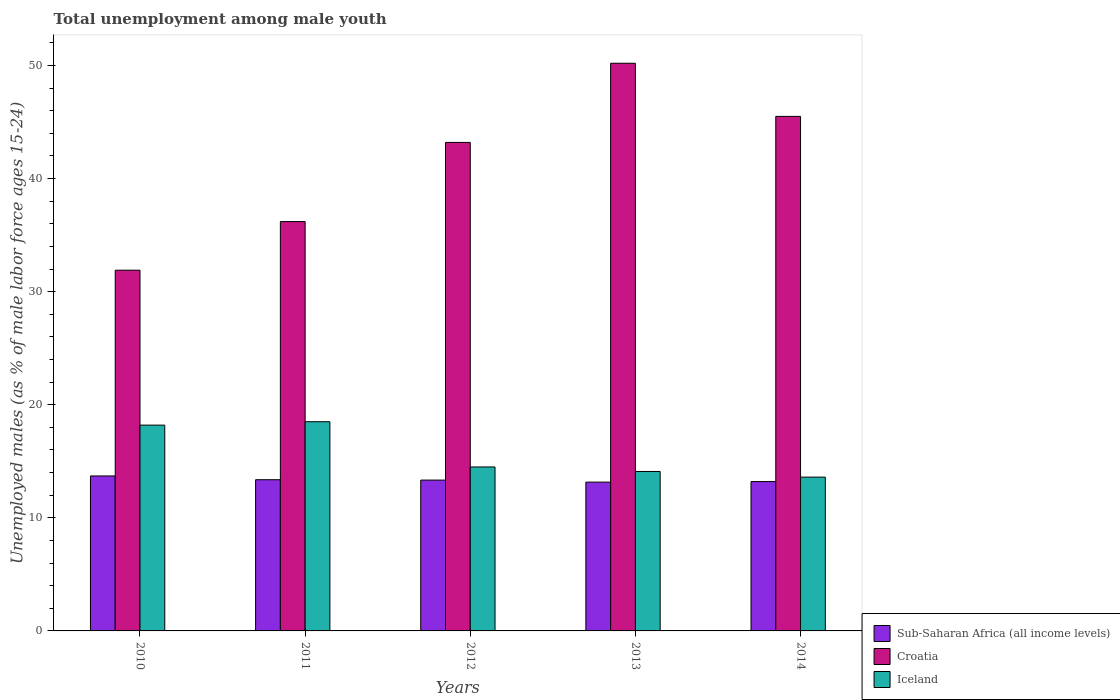How many different coloured bars are there?
Provide a succinct answer. 3. How many groups of bars are there?
Give a very brief answer. 5. How many bars are there on the 1st tick from the left?
Keep it short and to the point. 3. What is the percentage of unemployed males in in Sub-Saharan Africa (all income levels) in 2012?
Your answer should be compact. 13.34. Across all years, what is the maximum percentage of unemployed males in in Iceland?
Your answer should be very brief. 18.5. Across all years, what is the minimum percentage of unemployed males in in Sub-Saharan Africa (all income levels)?
Your answer should be compact. 13.16. In which year was the percentage of unemployed males in in Sub-Saharan Africa (all income levels) minimum?
Your response must be concise. 2013. What is the total percentage of unemployed males in in Sub-Saharan Africa (all income levels) in the graph?
Keep it short and to the point. 66.78. What is the difference between the percentage of unemployed males in in Croatia in 2012 and that in 2014?
Your response must be concise. -2.3. What is the difference between the percentage of unemployed males in in Iceland in 2014 and the percentage of unemployed males in in Sub-Saharan Africa (all income levels) in 2013?
Provide a short and direct response. 0.44. What is the average percentage of unemployed males in in Croatia per year?
Your answer should be very brief. 41.4. In the year 2014, what is the difference between the percentage of unemployed males in in Croatia and percentage of unemployed males in in Sub-Saharan Africa (all income levels)?
Your answer should be compact. 32.29. In how many years, is the percentage of unemployed males in in Sub-Saharan Africa (all income levels) greater than 26 %?
Offer a very short reply. 0. What is the ratio of the percentage of unemployed males in in Croatia in 2010 to that in 2011?
Your answer should be very brief. 0.88. Is the percentage of unemployed males in in Iceland in 2011 less than that in 2013?
Your answer should be very brief. No. Is the difference between the percentage of unemployed males in in Croatia in 2011 and 2013 greater than the difference between the percentage of unemployed males in in Sub-Saharan Africa (all income levels) in 2011 and 2013?
Ensure brevity in your answer.  No. What is the difference between the highest and the second highest percentage of unemployed males in in Iceland?
Give a very brief answer. 0.3. What is the difference between the highest and the lowest percentage of unemployed males in in Sub-Saharan Africa (all income levels)?
Your answer should be compact. 0.55. In how many years, is the percentage of unemployed males in in Sub-Saharan Africa (all income levels) greater than the average percentage of unemployed males in in Sub-Saharan Africa (all income levels) taken over all years?
Your answer should be compact. 2. Is the sum of the percentage of unemployed males in in Sub-Saharan Africa (all income levels) in 2013 and 2014 greater than the maximum percentage of unemployed males in in Croatia across all years?
Make the answer very short. No. What does the 1st bar from the left in 2011 represents?
Give a very brief answer. Sub-Saharan Africa (all income levels). What does the 2nd bar from the right in 2014 represents?
Keep it short and to the point. Croatia. How many bars are there?
Your answer should be very brief. 15. Are all the bars in the graph horizontal?
Your answer should be compact. No. Are the values on the major ticks of Y-axis written in scientific E-notation?
Your answer should be compact. No. Does the graph contain any zero values?
Offer a very short reply. No. Does the graph contain grids?
Offer a very short reply. No. Where does the legend appear in the graph?
Ensure brevity in your answer.  Bottom right. How many legend labels are there?
Your answer should be very brief. 3. What is the title of the graph?
Keep it short and to the point. Total unemployment among male youth. Does "Morocco" appear as one of the legend labels in the graph?
Your response must be concise. No. What is the label or title of the Y-axis?
Provide a short and direct response. Unemployed males (as % of male labor force ages 15-24). What is the Unemployed males (as % of male labor force ages 15-24) of Sub-Saharan Africa (all income levels) in 2010?
Your response must be concise. 13.7. What is the Unemployed males (as % of male labor force ages 15-24) in Croatia in 2010?
Provide a succinct answer. 31.9. What is the Unemployed males (as % of male labor force ages 15-24) in Iceland in 2010?
Keep it short and to the point. 18.2. What is the Unemployed males (as % of male labor force ages 15-24) of Sub-Saharan Africa (all income levels) in 2011?
Your response must be concise. 13.37. What is the Unemployed males (as % of male labor force ages 15-24) in Croatia in 2011?
Offer a very short reply. 36.2. What is the Unemployed males (as % of male labor force ages 15-24) of Iceland in 2011?
Offer a very short reply. 18.5. What is the Unemployed males (as % of male labor force ages 15-24) in Sub-Saharan Africa (all income levels) in 2012?
Give a very brief answer. 13.34. What is the Unemployed males (as % of male labor force ages 15-24) in Croatia in 2012?
Offer a terse response. 43.2. What is the Unemployed males (as % of male labor force ages 15-24) of Sub-Saharan Africa (all income levels) in 2013?
Ensure brevity in your answer.  13.16. What is the Unemployed males (as % of male labor force ages 15-24) in Croatia in 2013?
Offer a terse response. 50.2. What is the Unemployed males (as % of male labor force ages 15-24) in Iceland in 2013?
Provide a succinct answer. 14.1. What is the Unemployed males (as % of male labor force ages 15-24) of Sub-Saharan Africa (all income levels) in 2014?
Make the answer very short. 13.21. What is the Unemployed males (as % of male labor force ages 15-24) in Croatia in 2014?
Provide a short and direct response. 45.5. What is the Unemployed males (as % of male labor force ages 15-24) of Iceland in 2014?
Ensure brevity in your answer.  13.6. Across all years, what is the maximum Unemployed males (as % of male labor force ages 15-24) of Sub-Saharan Africa (all income levels)?
Your answer should be very brief. 13.7. Across all years, what is the maximum Unemployed males (as % of male labor force ages 15-24) of Croatia?
Offer a very short reply. 50.2. Across all years, what is the maximum Unemployed males (as % of male labor force ages 15-24) of Iceland?
Offer a very short reply. 18.5. Across all years, what is the minimum Unemployed males (as % of male labor force ages 15-24) in Sub-Saharan Africa (all income levels)?
Your answer should be very brief. 13.16. Across all years, what is the minimum Unemployed males (as % of male labor force ages 15-24) in Croatia?
Keep it short and to the point. 31.9. Across all years, what is the minimum Unemployed males (as % of male labor force ages 15-24) in Iceland?
Provide a succinct answer. 13.6. What is the total Unemployed males (as % of male labor force ages 15-24) in Sub-Saharan Africa (all income levels) in the graph?
Ensure brevity in your answer.  66.78. What is the total Unemployed males (as % of male labor force ages 15-24) in Croatia in the graph?
Provide a succinct answer. 207. What is the total Unemployed males (as % of male labor force ages 15-24) of Iceland in the graph?
Provide a short and direct response. 78.9. What is the difference between the Unemployed males (as % of male labor force ages 15-24) in Sub-Saharan Africa (all income levels) in 2010 and that in 2012?
Ensure brevity in your answer.  0.37. What is the difference between the Unemployed males (as % of male labor force ages 15-24) of Croatia in 2010 and that in 2012?
Make the answer very short. -11.3. What is the difference between the Unemployed males (as % of male labor force ages 15-24) of Iceland in 2010 and that in 2012?
Keep it short and to the point. 3.7. What is the difference between the Unemployed males (as % of male labor force ages 15-24) of Sub-Saharan Africa (all income levels) in 2010 and that in 2013?
Provide a succinct answer. 0.55. What is the difference between the Unemployed males (as % of male labor force ages 15-24) of Croatia in 2010 and that in 2013?
Offer a very short reply. -18.3. What is the difference between the Unemployed males (as % of male labor force ages 15-24) of Iceland in 2010 and that in 2013?
Offer a very short reply. 4.1. What is the difference between the Unemployed males (as % of male labor force ages 15-24) of Sub-Saharan Africa (all income levels) in 2010 and that in 2014?
Your answer should be very brief. 0.5. What is the difference between the Unemployed males (as % of male labor force ages 15-24) of Croatia in 2010 and that in 2014?
Your answer should be compact. -13.6. What is the difference between the Unemployed males (as % of male labor force ages 15-24) in Iceland in 2010 and that in 2014?
Provide a short and direct response. 4.6. What is the difference between the Unemployed males (as % of male labor force ages 15-24) of Sub-Saharan Africa (all income levels) in 2011 and that in 2012?
Offer a terse response. 0.03. What is the difference between the Unemployed males (as % of male labor force ages 15-24) of Iceland in 2011 and that in 2012?
Your response must be concise. 4. What is the difference between the Unemployed males (as % of male labor force ages 15-24) in Sub-Saharan Africa (all income levels) in 2011 and that in 2013?
Ensure brevity in your answer.  0.21. What is the difference between the Unemployed males (as % of male labor force ages 15-24) in Croatia in 2011 and that in 2013?
Your answer should be compact. -14. What is the difference between the Unemployed males (as % of male labor force ages 15-24) in Sub-Saharan Africa (all income levels) in 2011 and that in 2014?
Ensure brevity in your answer.  0.16. What is the difference between the Unemployed males (as % of male labor force ages 15-24) of Croatia in 2011 and that in 2014?
Ensure brevity in your answer.  -9.3. What is the difference between the Unemployed males (as % of male labor force ages 15-24) of Sub-Saharan Africa (all income levels) in 2012 and that in 2013?
Offer a very short reply. 0.18. What is the difference between the Unemployed males (as % of male labor force ages 15-24) in Iceland in 2012 and that in 2013?
Give a very brief answer. 0.4. What is the difference between the Unemployed males (as % of male labor force ages 15-24) in Sub-Saharan Africa (all income levels) in 2012 and that in 2014?
Offer a terse response. 0.13. What is the difference between the Unemployed males (as % of male labor force ages 15-24) in Croatia in 2012 and that in 2014?
Make the answer very short. -2.3. What is the difference between the Unemployed males (as % of male labor force ages 15-24) of Iceland in 2012 and that in 2014?
Give a very brief answer. 0.9. What is the difference between the Unemployed males (as % of male labor force ages 15-24) of Sub-Saharan Africa (all income levels) in 2013 and that in 2014?
Offer a very short reply. -0.05. What is the difference between the Unemployed males (as % of male labor force ages 15-24) of Sub-Saharan Africa (all income levels) in 2010 and the Unemployed males (as % of male labor force ages 15-24) of Croatia in 2011?
Offer a terse response. -22.5. What is the difference between the Unemployed males (as % of male labor force ages 15-24) of Sub-Saharan Africa (all income levels) in 2010 and the Unemployed males (as % of male labor force ages 15-24) of Iceland in 2011?
Offer a terse response. -4.8. What is the difference between the Unemployed males (as % of male labor force ages 15-24) in Sub-Saharan Africa (all income levels) in 2010 and the Unemployed males (as % of male labor force ages 15-24) in Croatia in 2012?
Provide a succinct answer. -29.5. What is the difference between the Unemployed males (as % of male labor force ages 15-24) of Sub-Saharan Africa (all income levels) in 2010 and the Unemployed males (as % of male labor force ages 15-24) of Iceland in 2012?
Offer a terse response. -0.8. What is the difference between the Unemployed males (as % of male labor force ages 15-24) in Croatia in 2010 and the Unemployed males (as % of male labor force ages 15-24) in Iceland in 2012?
Ensure brevity in your answer.  17.4. What is the difference between the Unemployed males (as % of male labor force ages 15-24) of Sub-Saharan Africa (all income levels) in 2010 and the Unemployed males (as % of male labor force ages 15-24) of Croatia in 2013?
Your answer should be very brief. -36.5. What is the difference between the Unemployed males (as % of male labor force ages 15-24) in Sub-Saharan Africa (all income levels) in 2010 and the Unemployed males (as % of male labor force ages 15-24) in Iceland in 2013?
Give a very brief answer. -0.4. What is the difference between the Unemployed males (as % of male labor force ages 15-24) in Croatia in 2010 and the Unemployed males (as % of male labor force ages 15-24) in Iceland in 2013?
Offer a very short reply. 17.8. What is the difference between the Unemployed males (as % of male labor force ages 15-24) of Sub-Saharan Africa (all income levels) in 2010 and the Unemployed males (as % of male labor force ages 15-24) of Croatia in 2014?
Provide a short and direct response. -31.8. What is the difference between the Unemployed males (as % of male labor force ages 15-24) in Sub-Saharan Africa (all income levels) in 2010 and the Unemployed males (as % of male labor force ages 15-24) in Iceland in 2014?
Keep it short and to the point. 0.1. What is the difference between the Unemployed males (as % of male labor force ages 15-24) in Croatia in 2010 and the Unemployed males (as % of male labor force ages 15-24) in Iceland in 2014?
Your response must be concise. 18.3. What is the difference between the Unemployed males (as % of male labor force ages 15-24) in Sub-Saharan Africa (all income levels) in 2011 and the Unemployed males (as % of male labor force ages 15-24) in Croatia in 2012?
Your response must be concise. -29.83. What is the difference between the Unemployed males (as % of male labor force ages 15-24) in Sub-Saharan Africa (all income levels) in 2011 and the Unemployed males (as % of male labor force ages 15-24) in Iceland in 2012?
Ensure brevity in your answer.  -1.13. What is the difference between the Unemployed males (as % of male labor force ages 15-24) in Croatia in 2011 and the Unemployed males (as % of male labor force ages 15-24) in Iceland in 2012?
Offer a terse response. 21.7. What is the difference between the Unemployed males (as % of male labor force ages 15-24) of Sub-Saharan Africa (all income levels) in 2011 and the Unemployed males (as % of male labor force ages 15-24) of Croatia in 2013?
Keep it short and to the point. -36.83. What is the difference between the Unemployed males (as % of male labor force ages 15-24) in Sub-Saharan Africa (all income levels) in 2011 and the Unemployed males (as % of male labor force ages 15-24) in Iceland in 2013?
Offer a terse response. -0.73. What is the difference between the Unemployed males (as % of male labor force ages 15-24) in Croatia in 2011 and the Unemployed males (as % of male labor force ages 15-24) in Iceland in 2013?
Provide a short and direct response. 22.1. What is the difference between the Unemployed males (as % of male labor force ages 15-24) of Sub-Saharan Africa (all income levels) in 2011 and the Unemployed males (as % of male labor force ages 15-24) of Croatia in 2014?
Give a very brief answer. -32.13. What is the difference between the Unemployed males (as % of male labor force ages 15-24) of Sub-Saharan Africa (all income levels) in 2011 and the Unemployed males (as % of male labor force ages 15-24) of Iceland in 2014?
Keep it short and to the point. -0.23. What is the difference between the Unemployed males (as % of male labor force ages 15-24) of Croatia in 2011 and the Unemployed males (as % of male labor force ages 15-24) of Iceland in 2014?
Provide a short and direct response. 22.6. What is the difference between the Unemployed males (as % of male labor force ages 15-24) in Sub-Saharan Africa (all income levels) in 2012 and the Unemployed males (as % of male labor force ages 15-24) in Croatia in 2013?
Your response must be concise. -36.86. What is the difference between the Unemployed males (as % of male labor force ages 15-24) in Sub-Saharan Africa (all income levels) in 2012 and the Unemployed males (as % of male labor force ages 15-24) in Iceland in 2013?
Ensure brevity in your answer.  -0.76. What is the difference between the Unemployed males (as % of male labor force ages 15-24) in Croatia in 2012 and the Unemployed males (as % of male labor force ages 15-24) in Iceland in 2013?
Provide a succinct answer. 29.1. What is the difference between the Unemployed males (as % of male labor force ages 15-24) in Sub-Saharan Africa (all income levels) in 2012 and the Unemployed males (as % of male labor force ages 15-24) in Croatia in 2014?
Offer a very short reply. -32.16. What is the difference between the Unemployed males (as % of male labor force ages 15-24) in Sub-Saharan Africa (all income levels) in 2012 and the Unemployed males (as % of male labor force ages 15-24) in Iceland in 2014?
Keep it short and to the point. -0.26. What is the difference between the Unemployed males (as % of male labor force ages 15-24) of Croatia in 2012 and the Unemployed males (as % of male labor force ages 15-24) of Iceland in 2014?
Ensure brevity in your answer.  29.6. What is the difference between the Unemployed males (as % of male labor force ages 15-24) of Sub-Saharan Africa (all income levels) in 2013 and the Unemployed males (as % of male labor force ages 15-24) of Croatia in 2014?
Your answer should be compact. -32.34. What is the difference between the Unemployed males (as % of male labor force ages 15-24) in Sub-Saharan Africa (all income levels) in 2013 and the Unemployed males (as % of male labor force ages 15-24) in Iceland in 2014?
Offer a terse response. -0.44. What is the difference between the Unemployed males (as % of male labor force ages 15-24) of Croatia in 2013 and the Unemployed males (as % of male labor force ages 15-24) of Iceland in 2014?
Provide a short and direct response. 36.6. What is the average Unemployed males (as % of male labor force ages 15-24) in Sub-Saharan Africa (all income levels) per year?
Offer a very short reply. 13.36. What is the average Unemployed males (as % of male labor force ages 15-24) of Croatia per year?
Your response must be concise. 41.4. What is the average Unemployed males (as % of male labor force ages 15-24) in Iceland per year?
Provide a short and direct response. 15.78. In the year 2010, what is the difference between the Unemployed males (as % of male labor force ages 15-24) in Sub-Saharan Africa (all income levels) and Unemployed males (as % of male labor force ages 15-24) in Croatia?
Make the answer very short. -18.2. In the year 2010, what is the difference between the Unemployed males (as % of male labor force ages 15-24) in Sub-Saharan Africa (all income levels) and Unemployed males (as % of male labor force ages 15-24) in Iceland?
Ensure brevity in your answer.  -4.5. In the year 2011, what is the difference between the Unemployed males (as % of male labor force ages 15-24) in Sub-Saharan Africa (all income levels) and Unemployed males (as % of male labor force ages 15-24) in Croatia?
Offer a terse response. -22.83. In the year 2011, what is the difference between the Unemployed males (as % of male labor force ages 15-24) in Sub-Saharan Africa (all income levels) and Unemployed males (as % of male labor force ages 15-24) in Iceland?
Offer a terse response. -5.13. In the year 2011, what is the difference between the Unemployed males (as % of male labor force ages 15-24) in Croatia and Unemployed males (as % of male labor force ages 15-24) in Iceland?
Your response must be concise. 17.7. In the year 2012, what is the difference between the Unemployed males (as % of male labor force ages 15-24) of Sub-Saharan Africa (all income levels) and Unemployed males (as % of male labor force ages 15-24) of Croatia?
Offer a terse response. -29.86. In the year 2012, what is the difference between the Unemployed males (as % of male labor force ages 15-24) in Sub-Saharan Africa (all income levels) and Unemployed males (as % of male labor force ages 15-24) in Iceland?
Ensure brevity in your answer.  -1.16. In the year 2012, what is the difference between the Unemployed males (as % of male labor force ages 15-24) in Croatia and Unemployed males (as % of male labor force ages 15-24) in Iceland?
Your answer should be very brief. 28.7. In the year 2013, what is the difference between the Unemployed males (as % of male labor force ages 15-24) of Sub-Saharan Africa (all income levels) and Unemployed males (as % of male labor force ages 15-24) of Croatia?
Offer a terse response. -37.04. In the year 2013, what is the difference between the Unemployed males (as % of male labor force ages 15-24) in Sub-Saharan Africa (all income levels) and Unemployed males (as % of male labor force ages 15-24) in Iceland?
Offer a very short reply. -0.94. In the year 2013, what is the difference between the Unemployed males (as % of male labor force ages 15-24) of Croatia and Unemployed males (as % of male labor force ages 15-24) of Iceland?
Offer a very short reply. 36.1. In the year 2014, what is the difference between the Unemployed males (as % of male labor force ages 15-24) in Sub-Saharan Africa (all income levels) and Unemployed males (as % of male labor force ages 15-24) in Croatia?
Your response must be concise. -32.29. In the year 2014, what is the difference between the Unemployed males (as % of male labor force ages 15-24) in Sub-Saharan Africa (all income levels) and Unemployed males (as % of male labor force ages 15-24) in Iceland?
Provide a short and direct response. -0.39. In the year 2014, what is the difference between the Unemployed males (as % of male labor force ages 15-24) in Croatia and Unemployed males (as % of male labor force ages 15-24) in Iceland?
Ensure brevity in your answer.  31.9. What is the ratio of the Unemployed males (as % of male labor force ages 15-24) in Sub-Saharan Africa (all income levels) in 2010 to that in 2011?
Provide a succinct answer. 1.02. What is the ratio of the Unemployed males (as % of male labor force ages 15-24) of Croatia in 2010 to that in 2011?
Your response must be concise. 0.88. What is the ratio of the Unemployed males (as % of male labor force ages 15-24) in Iceland in 2010 to that in 2011?
Offer a terse response. 0.98. What is the ratio of the Unemployed males (as % of male labor force ages 15-24) in Sub-Saharan Africa (all income levels) in 2010 to that in 2012?
Give a very brief answer. 1.03. What is the ratio of the Unemployed males (as % of male labor force ages 15-24) in Croatia in 2010 to that in 2012?
Give a very brief answer. 0.74. What is the ratio of the Unemployed males (as % of male labor force ages 15-24) of Iceland in 2010 to that in 2012?
Offer a terse response. 1.26. What is the ratio of the Unemployed males (as % of male labor force ages 15-24) in Sub-Saharan Africa (all income levels) in 2010 to that in 2013?
Keep it short and to the point. 1.04. What is the ratio of the Unemployed males (as % of male labor force ages 15-24) in Croatia in 2010 to that in 2013?
Offer a very short reply. 0.64. What is the ratio of the Unemployed males (as % of male labor force ages 15-24) of Iceland in 2010 to that in 2013?
Provide a succinct answer. 1.29. What is the ratio of the Unemployed males (as % of male labor force ages 15-24) of Sub-Saharan Africa (all income levels) in 2010 to that in 2014?
Provide a short and direct response. 1.04. What is the ratio of the Unemployed males (as % of male labor force ages 15-24) of Croatia in 2010 to that in 2014?
Provide a short and direct response. 0.7. What is the ratio of the Unemployed males (as % of male labor force ages 15-24) of Iceland in 2010 to that in 2014?
Provide a succinct answer. 1.34. What is the ratio of the Unemployed males (as % of male labor force ages 15-24) of Croatia in 2011 to that in 2012?
Provide a short and direct response. 0.84. What is the ratio of the Unemployed males (as % of male labor force ages 15-24) of Iceland in 2011 to that in 2012?
Provide a short and direct response. 1.28. What is the ratio of the Unemployed males (as % of male labor force ages 15-24) in Sub-Saharan Africa (all income levels) in 2011 to that in 2013?
Give a very brief answer. 1.02. What is the ratio of the Unemployed males (as % of male labor force ages 15-24) of Croatia in 2011 to that in 2013?
Make the answer very short. 0.72. What is the ratio of the Unemployed males (as % of male labor force ages 15-24) in Iceland in 2011 to that in 2013?
Your response must be concise. 1.31. What is the ratio of the Unemployed males (as % of male labor force ages 15-24) of Sub-Saharan Africa (all income levels) in 2011 to that in 2014?
Offer a terse response. 1.01. What is the ratio of the Unemployed males (as % of male labor force ages 15-24) in Croatia in 2011 to that in 2014?
Give a very brief answer. 0.8. What is the ratio of the Unemployed males (as % of male labor force ages 15-24) of Iceland in 2011 to that in 2014?
Give a very brief answer. 1.36. What is the ratio of the Unemployed males (as % of male labor force ages 15-24) of Sub-Saharan Africa (all income levels) in 2012 to that in 2013?
Offer a terse response. 1.01. What is the ratio of the Unemployed males (as % of male labor force ages 15-24) in Croatia in 2012 to that in 2013?
Offer a terse response. 0.86. What is the ratio of the Unemployed males (as % of male labor force ages 15-24) in Iceland in 2012 to that in 2013?
Provide a short and direct response. 1.03. What is the ratio of the Unemployed males (as % of male labor force ages 15-24) in Sub-Saharan Africa (all income levels) in 2012 to that in 2014?
Your answer should be compact. 1.01. What is the ratio of the Unemployed males (as % of male labor force ages 15-24) in Croatia in 2012 to that in 2014?
Offer a terse response. 0.95. What is the ratio of the Unemployed males (as % of male labor force ages 15-24) of Iceland in 2012 to that in 2014?
Offer a very short reply. 1.07. What is the ratio of the Unemployed males (as % of male labor force ages 15-24) in Sub-Saharan Africa (all income levels) in 2013 to that in 2014?
Provide a succinct answer. 1. What is the ratio of the Unemployed males (as % of male labor force ages 15-24) in Croatia in 2013 to that in 2014?
Ensure brevity in your answer.  1.1. What is the ratio of the Unemployed males (as % of male labor force ages 15-24) of Iceland in 2013 to that in 2014?
Make the answer very short. 1.04. What is the difference between the highest and the second highest Unemployed males (as % of male labor force ages 15-24) of Sub-Saharan Africa (all income levels)?
Your answer should be compact. 0.33. What is the difference between the highest and the lowest Unemployed males (as % of male labor force ages 15-24) of Sub-Saharan Africa (all income levels)?
Your answer should be very brief. 0.55. 